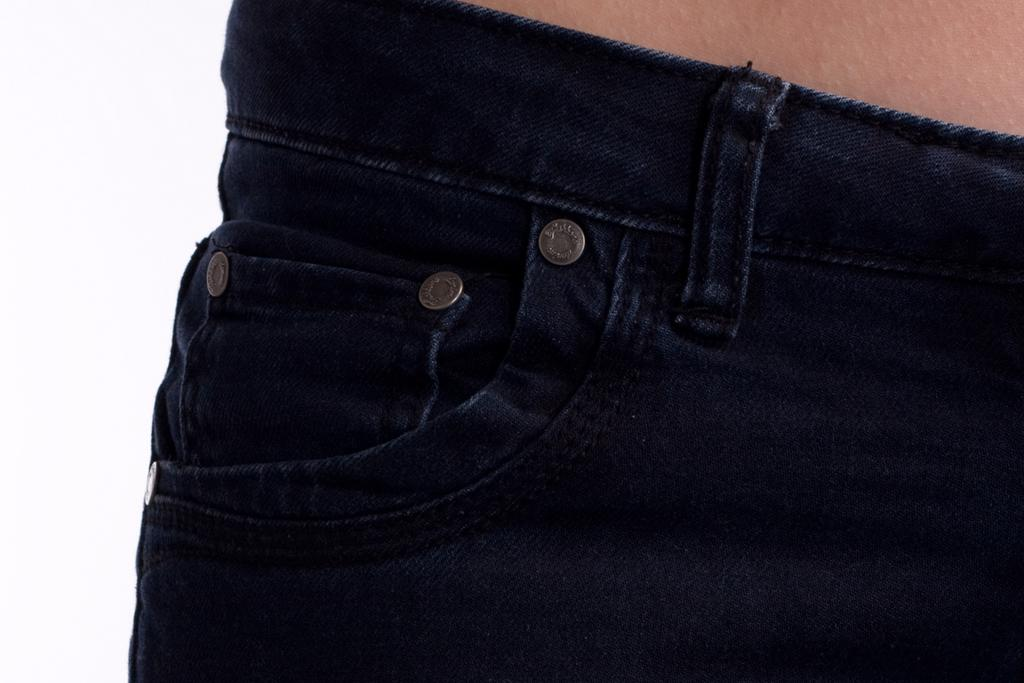What type of clothing item is in the center of the image? There is a pair of dark blue jeans in the image. Can you describe the location of the jeans in the image? The jeans are located in the center of the image. What type of ghost can be seen interacting with the jeans in the image? There is no ghost present in the image, and therefore no such interaction can be observed. 